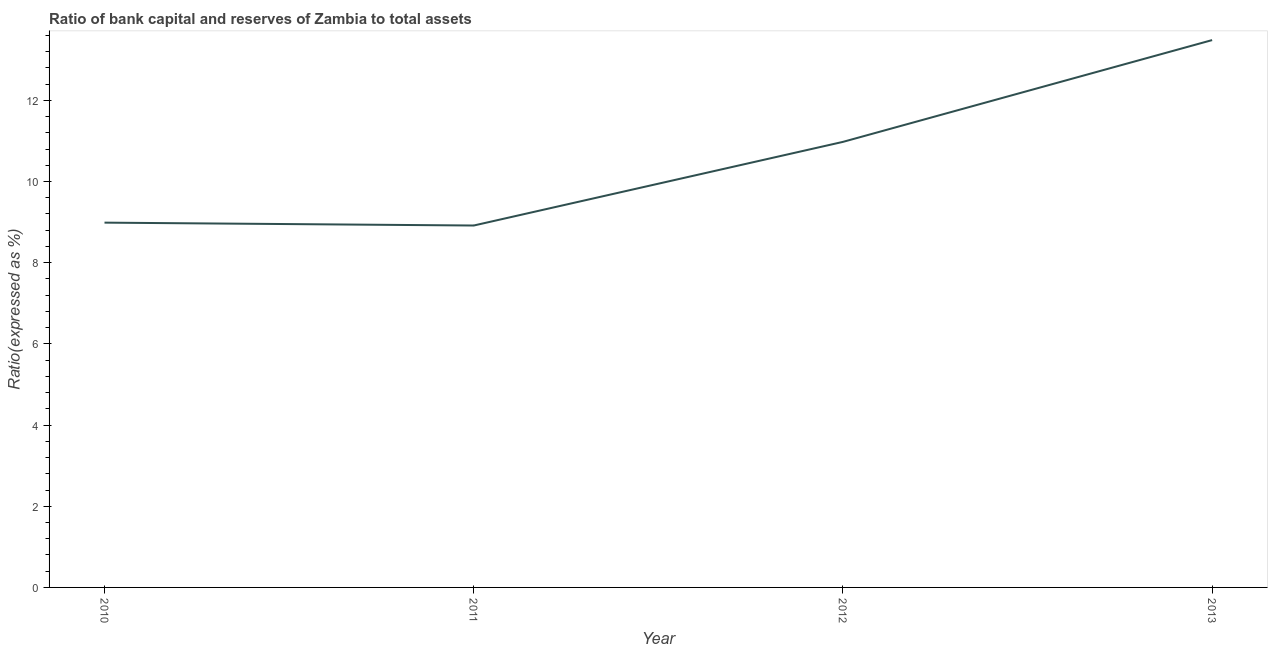What is the bank capital to assets ratio in 2013?
Make the answer very short. 13.48. Across all years, what is the maximum bank capital to assets ratio?
Provide a succinct answer. 13.48. Across all years, what is the minimum bank capital to assets ratio?
Give a very brief answer. 8.92. In which year was the bank capital to assets ratio minimum?
Provide a short and direct response. 2011. What is the sum of the bank capital to assets ratio?
Provide a succinct answer. 42.36. What is the difference between the bank capital to assets ratio in 2011 and 2012?
Make the answer very short. -2.06. What is the average bank capital to assets ratio per year?
Your response must be concise. 10.59. What is the median bank capital to assets ratio?
Your answer should be compact. 9.98. What is the ratio of the bank capital to assets ratio in 2010 to that in 2012?
Give a very brief answer. 0.82. Is the bank capital to assets ratio in 2011 less than that in 2013?
Offer a very short reply. Yes. Is the difference between the bank capital to assets ratio in 2010 and 2011 greater than the difference between any two years?
Give a very brief answer. No. What is the difference between the highest and the second highest bank capital to assets ratio?
Ensure brevity in your answer.  2.51. Is the sum of the bank capital to assets ratio in 2011 and 2012 greater than the maximum bank capital to assets ratio across all years?
Offer a very short reply. Yes. What is the difference between the highest and the lowest bank capital to assets ratio?
Offer a very short reply. 4.57. Does the bank capital to assets ratio monotonically increase over the years?
Offer a terse response. No. How many lines are there?
Your answer should be very brief. 1. How many years are there in the graph?
Offer a terse response. 4. What is the difference between two consecutive major ticks on the Y-axis?
Your response must be concise. 2. Does the graph contain grids?
Your answer should be compact. No. What is the title of the graph?
Your response must be concise. Ratio of bank capital and reserves of Zambia to total assets. What is the label or title of the X-axis?
Give a very brief answer. Year. What is the label or title of the Y-axis?
Make the answer very short. Ratio(expressed as %). What is the Ratio(expressed as %) of 2010?
Your response must be concise. 8.99. What is the Ratio(expressed as %) of 2011?
Keep it short and to the point. 8.92. What is the Ratio(expressed as %) in 2012?
Keep it short and to the point. 10.98. What is the Ratio(expressed as %) of 2013?
Your response must be concise. 13.48. What is the difference between the Ratio(expressed as %) in 2010 and 2011?
Provide a succinct answer. 0.07. What is the difference between the Ratio(expressed as %) in 2010 and 2012?
Your answer should be compact. -1.99. What is the difference between the Ratio(expressed as %) in 2010 and 2013?
Your answer should be very brief. -4.5. What is the difference between the Ratio(expressed as %) in 2011 and 2012?
Your answer should be very brief. -2.06. What is the difference between the Ratio(expressed as %) in 2011 and 2013?
Offer a very short reply. -4.57. What is the difference between the Ratio(expressed as %) in 2012 and 2013?
Provide a short and direct response. -2.51. What is the ratio of the Ratio(expressed as %) in 2010 to that in 2012?
Provide a succinct answer. 0.82. What is the ratio of the Ratio(expressed as %) in 2010 to that in 2013?
Provide a short and direct response. 0.67. What is the ratio of the Ratio(expressed as %) in 2011 to that in 2012?
Make the answer very short. 0.81. What is the ratio of the Ratio(expressed as %) in 2011 to that in 2013?
Ensure brevity in your answer.  0.66. What is the ratio of the Ratio(expressed as %) in 2012 to that in 2013?
Ensure brevity in your answer.  0.81. 